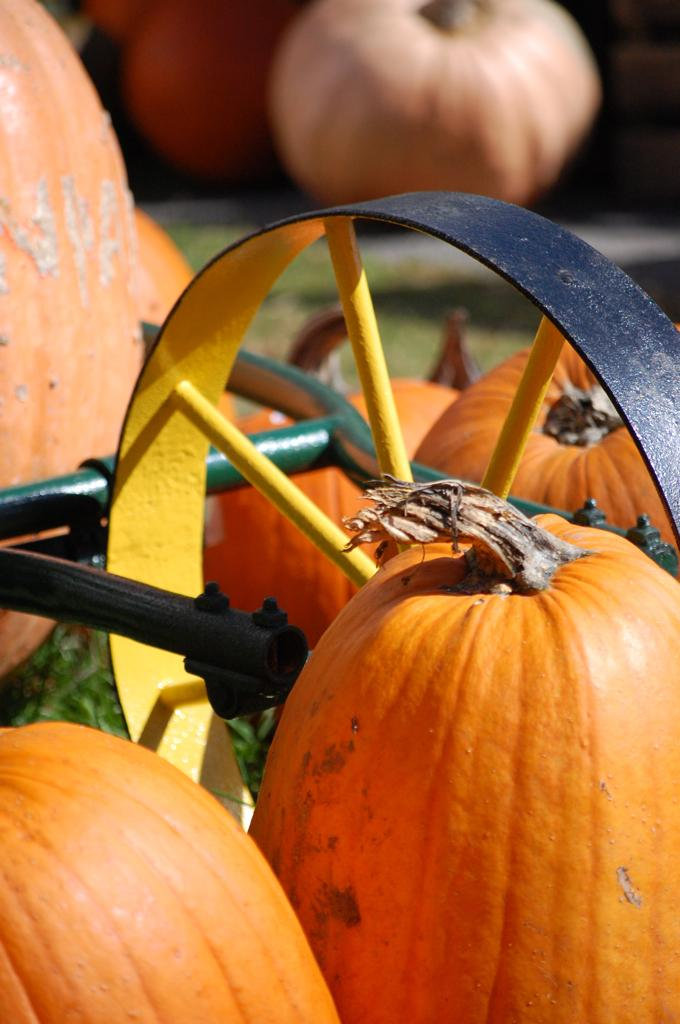What type of vegetable is present in the image? There are pumpkins in the image. What is the object placed on the grass? The facts do not specify the object on the grass, so we cannot answer this question definitively. Can you describe the background of the image? The background of the image is blurry. How many cattle can be seen grazing in the image? There are no cattle present in the image. What type of toe is visible in the image? There are no toes visible in the image. 